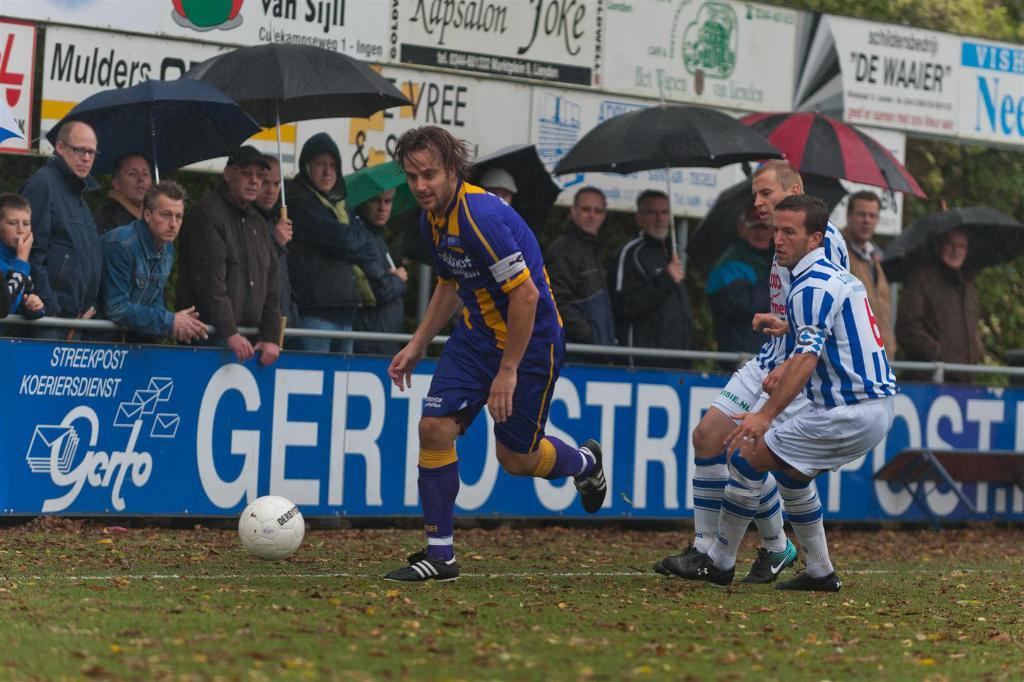<image>
Describe the image concisely. Two soccer players are chasing after another soccer player, in control of the ball, in front of a blue banner from Streetpost Koeriersdienst. 